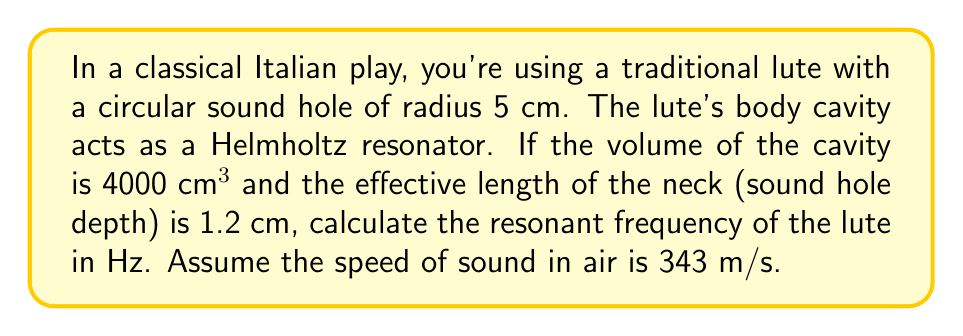Could you help me with this problem? To solve this problem, we'll use the Helmholtz resonator equation:

$$f = \frac{c}{2\pi}\sqrt{\frac{A}{VL}}$$

Where:
$f$ = resonant frequency (Hz)
$c$ = speed of sound in air (343 m/s)
$A$ = area of the sound hole (m²)
$V$ = volume of the cavity (m³)
$L$ = effective length of the neck (m)

Step 1: Calculate the area of the sound hole
$$A = \pi r^2 = \pi (0.05\text{ m})^2 = 7.854 \times 10^{-3} \text{ m}^2$$

Step 2: Convert volume to m³
$$V = 4000 \text{ cm}^3 = 4 \times 10^{-3} \text{ m}^3$$

Step 3: Convert effective length to m
$$L = 1.2 \text{ cm} = 1.2 \times 10^{-2} \text{ m}$$

Step 4: Substitute values into the Helmholtz resonator equation
$$f = \frac{343}{2\pi}\sqrt{\frac{7.854 \times 10^{-3}}{(4 \times 10^{-3})(1.2 \times 10^{-2})}}$$

Step 5: Simplify and calculate
$$f = \frac{343}{2\pi}\sqrt{\frac{7.854 \times 10^{-3}}{4.8 \times 10^{-5}}} \approx 223.7 \text{ Hz}$$
Answer: 223.7 Hz 